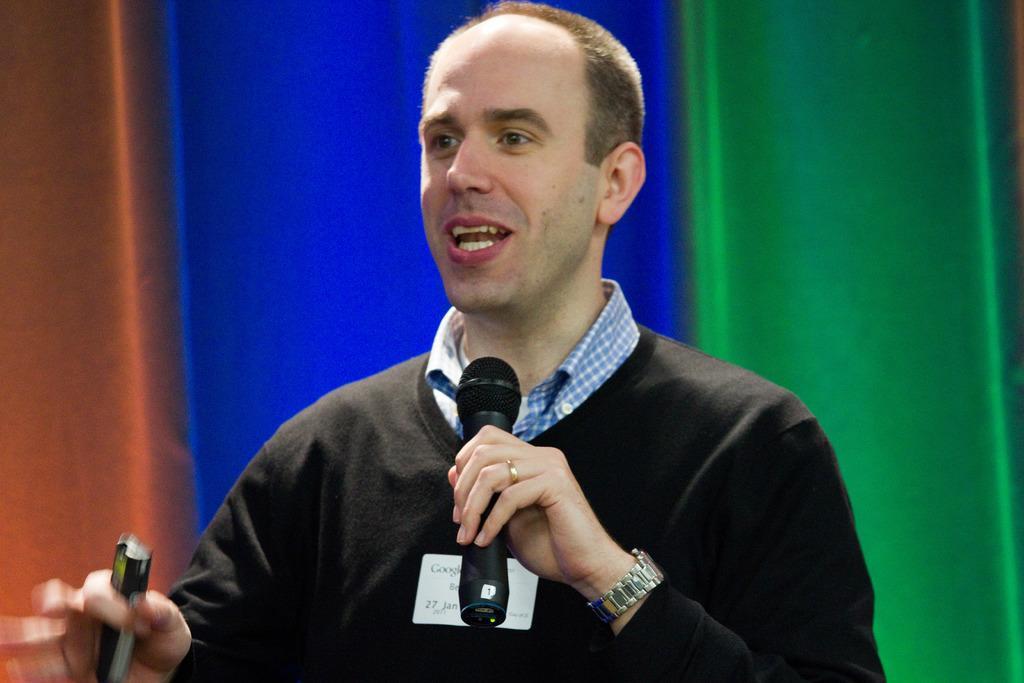Can you describe this image briefly? In this picture we can see a man speaking something, he is holding a microphone and something, he wore a black color t-shirt and a watch, there is a blurry background. 